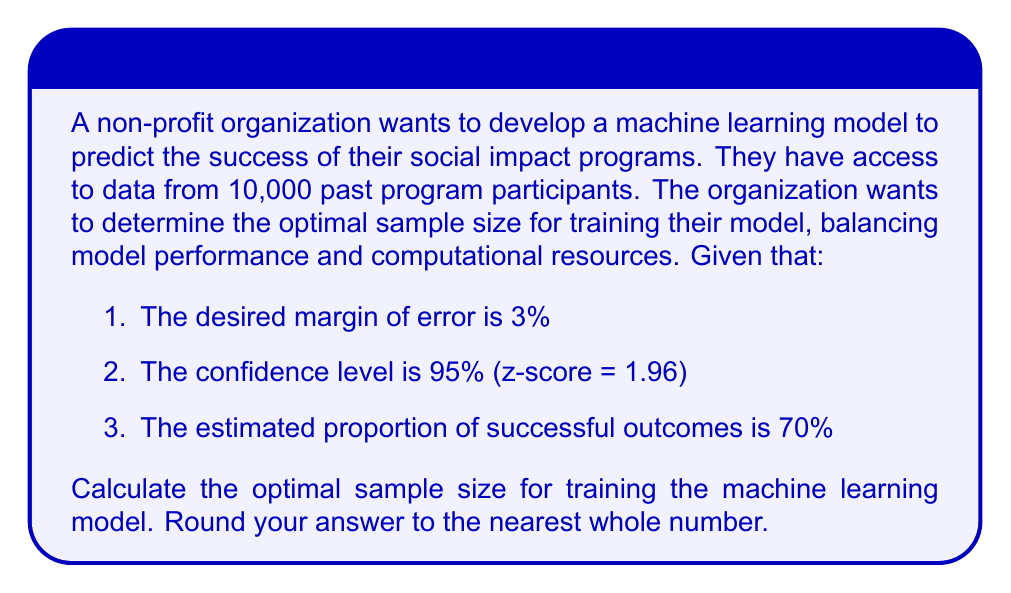Can you answer this question? To determine the optimal sample size for a machine learning model, we can use the formula for sample size calculation in statistical analysis:

$$ n = \frac{z^2 \cdot p(1-p)}{e^2} $$

Where:
$n$ = sample size
$z$ = z-score corresponding to the confidence level
$p$ = estimated proportion of successful outcomes
$e$ = margin of error

Given:
$z = 1.96$ (95% confidence level)
$p = 0.70$ (70% estimated success rate)
$e = 0.03$ (3% margin of error)

Let's substitute these values into the formula:

$$ n = \frac{1.96^2 \cdot 0.70(1-0.70)}{0.03^2} $$

$$ n = \frac{3.8416 \cdot 0.70 \cdot 0.30}{0.0009} $$

$$ n = \frac{0.80674}{0.0009} $$

$$ n = 896.37 $$

Rounding to the nearest whole number, we get 896.

This sample size ensures that the model's predictions will be within 3% of the true value with 95% confidence, given the estimated success rate of 70%.

It's important to note that this is the minimum recommended sample size. In machine learning, having more data often leads to better model performance. Since the organization has access to data from 10,000 past participants, they may want to use a larger sample size if computational resources allow, to potentially improve the model's accuracy and generalization capabilities.
Answer: 896 